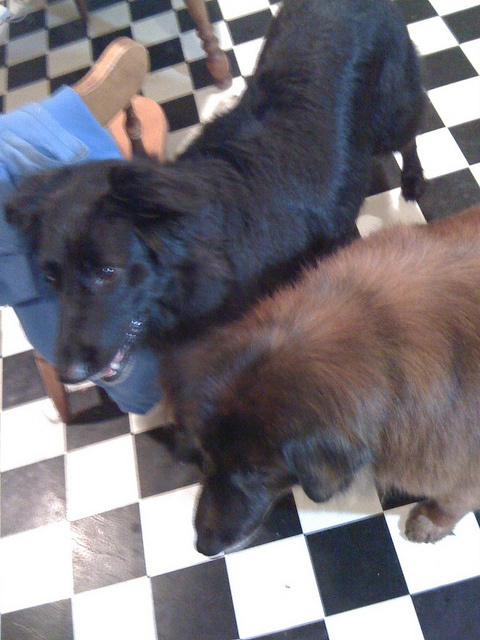Describe the objects in this image and their specific colors. I can see dog in darkgray, black, gray, and darkblue tones, dog in darkgray, gray, and black tones, and chair in darkgray, gray, lightblue, and tan tones in this image. 